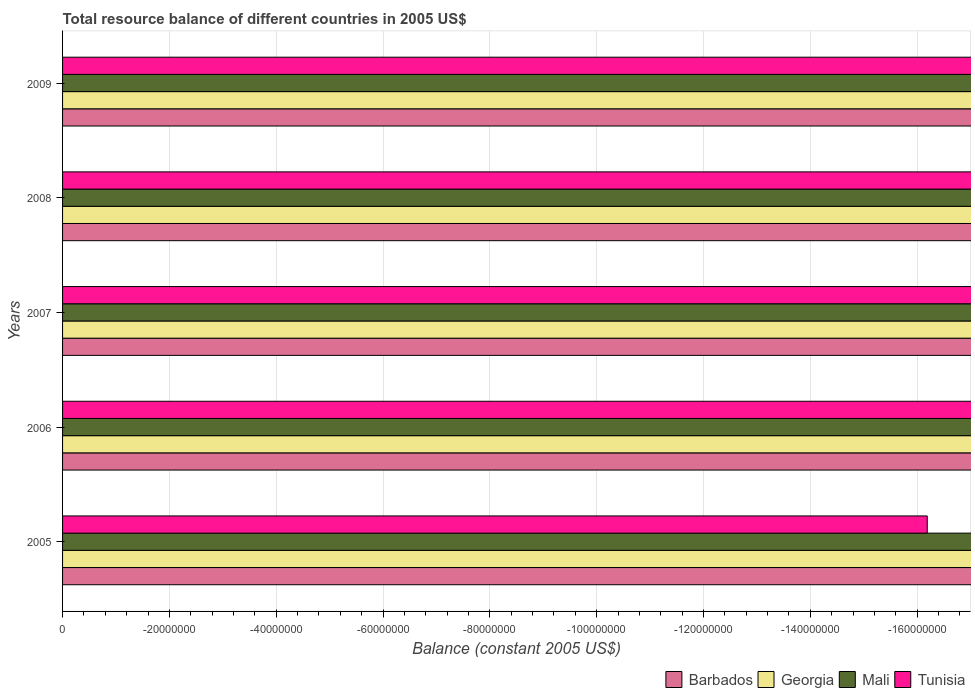Are the number of bars per tick equal to the number of legend labels?
Give a very brief answer. No. Are the number of bars on each tick of the Y-axis equal?
Offer a terse response. Yes. What is the label of the 3rd group of bars from the top?
Make the answer very short. 2007. In how many cases, is the number of bars for a given year not equal to the number of legend labels?
Make the answer very short. 5. Across all years, what is the minimum total resource balance in Mali?
Provide a succinct answer. 0. What is the average total resource balance in Barbados per year?
Provide a succinct answer. 0. In how many years, is the total resource balance in Barbados greater than -36000000 US$?
Ensure brevity in your answer.  0. In how many years, is the total resource balance in Georgia greater than the average total resource balance in Georgia taken over all years?
Offer a terse response. 0. Is it the case that in every year, the sum of the total resource balance in Barbados and total resource balance in Georgia is greater than the total resource balance in Mali?
Give a very brief answer. No. Does the graph contain grids?
Offer a very short reply. Yes. How are the legend labels stacked?
Offer a terse response. Horizontal. What is the title of the graph?
Your answer should be very brief. Total resource balance of different countries in 2005 US$. What is the label or title of the X-axis?
Your response must be concise. Balance (constant 2005 US$). What is the label or title of the Y-axis?
Provide a short and direct response. Years. What is the Balance (constant 2005 US$) in Barbados in 2005?
Your answer should be compact. 0. What is the Balance (constant 2005 US$) in Mali in 2005?
Keep it short and to the point. 0. What is the Balance (constant 2005 US$) in Tunisia in 2005?
Provide a succinct answer. 0. What is the Balance (constant 2005 US$) in Barbados in 2006?
Provide a succinct answer. 0. What is the Balance (constant 2005 US$) in Mali in 2006?
Your response must be concise. 0. What is the Balance (constant 2005 US$) of Tunisia in 2006?
Make the answer very short. 0. What is the Balance (constant 2005 US$) of Tunisia in 2007?
Your answer should be very brief. 0. What is the Balance (constant 2005 US$) of Georgia in 2008?
Provide a succinct answer. 0. What is the Balance (constant 2005 US$) in Barbados in 2009?
Your answer should be compact. 0. What is the Balance (constant 2005 US$) of Tunisia in 2009?
Offer a terse response. 0. What is the total Balance (constant 2005 US$) in Barbados in the graph?
Your answer should be very brief. 0. What is the total Balance (constant 2005 US$) of Georgia in the graph?
Make the answer very short. 0. What is the total Balance (constant 2005 US$) in Mali in the graph?
Your answer should be compact. 0. What is the total Balance (constant 2005 US$) of Tunisia in the graph?
Your answer should be compact. 0. What is the average Balance (constant 2005 US$) in Georgia per year?
Offer a terse response. 0. What is the average Balance (constant 2005 US$) in Tunisia per year?
Provide a short and direct response. 0. 